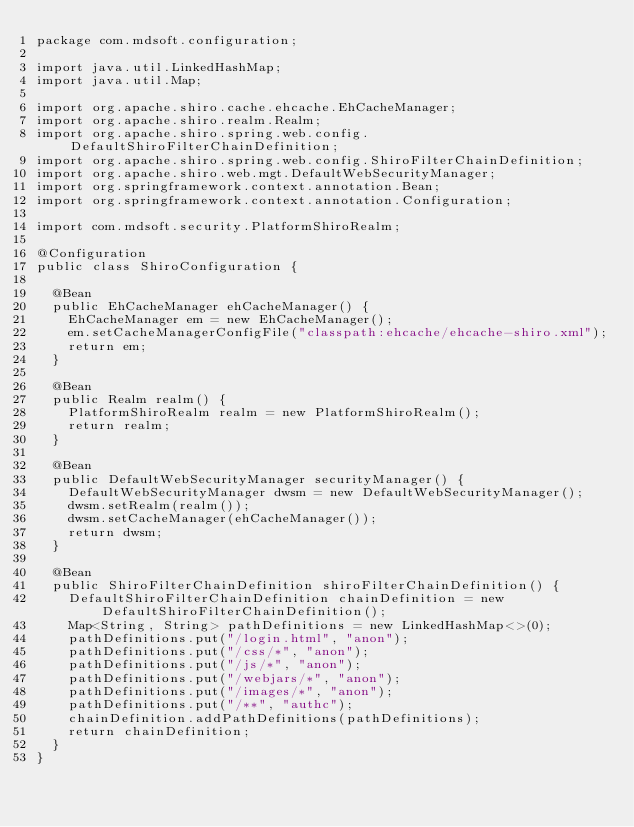<code> <loc_0><loc_0><loc_500><loc_500><_Java_>package com.mdsoft.configuration;

import java.util.LinkedHashMap;
import java.util.Map;

import org.apache.shiro.cache.ehcache.EhCacheManager;
import org.apache.shiro.realm.Realm;
import org.apache.shiro.spring.web.config.DefaultShiroFilterChainDefinition;
import org.apache.shiro.spring.web.config.ShiroFilterChainDefinition;
import org.apache.shiro.web.mgt.DefaultWebSecurityManager;
import org.springframework.context.annotation.Bean;
import org.springframework.context.annotation.Configuration;

import com.mdsoft.security.PlatformShiroRealm;

@Configuration
public class ShiroConfiguration {

	@Bean
	public EhCacheManager ehCacheManager() {
		EhCacheManager em = new EhCacheManager();
		em.setCacheManagerConfigFile("classpath:ehcache/ehcache-shiro.xml");
		return em;
	}

	@Bean
	public Realm realm() {
		PlatformShiroRealm realm = new PlatformShiroRealm();
		return realm;
	}

	@Bean
	public DefaultWebSecurityManager securityManager() {
		DefaultWebSecurityManager dwsm = new DefaultWebSecurityManager();
		dwsm.setRealm(realm());
		dwsm.setCacheManager(ehCacheManager());
		return dwsm;
	}

	@Bean
	public ShiroFilterChainDefinition shiroFilterChainDefinition() {
		DefaultShiroFilterChainDefinition chainDefinition = new DefaultShiroFilterChainDefinition();
		Map<String, String> pathDefinitions = new LinkedHashMap<>(0);
		pathDefinitions.put("/login.html", "anon");
		pathDefinitions.put("/css/*", "anon");
		pathDefinitions.put("/js/*", "anon");
		pathDefinitions.put("/webjars/*", "anon");
		pathDefinitions.put("/images/*", "anon");
		pathDefinitions.put("/**", "authc");
		chainDefinition.addPathDefinitions(pathDefinitions);
		return chainDefinition;
	}
}
</code> 